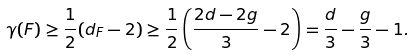Convert formula to latex. <formula><loc_0><loc_0><loc_500><loc_500>\gamma ( F ) \geq \frac { 1 } { 2 } ( d _ { F } - 2 ) \geq \frac { 1 } { 2 } \left ( \frac { 2 d - 2 g } { 3 } - 2 \right ) = \frac { d } { 3 } - \frac { g } { 3 } - 1 .</formula> 